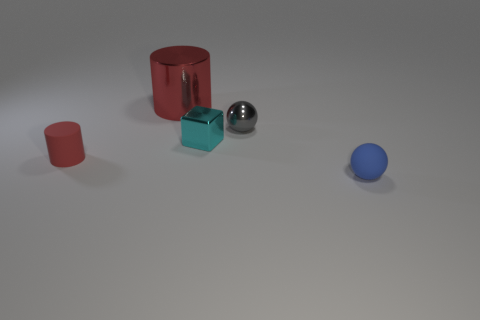Add 3 tiny matte cylinders. How many objects exist? 8 Subtract all balls. How many objects are left? 3 Add 2 red rubber cylinders. How many red rubber cylinders are left? 3 Add 2 small green blocks. How many small green blocks exist? 2 Subtract 0 blue cylinders. How many objects are left? 5 Subtract all tiny red metal balls. Subtract all tiny red rubber cylinders. How many objects are left? 4 